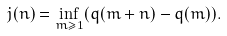Convert formula to latex. <formula><loc_0><loc_0><loc_500><loc_500>j ( n ) = \inf _ { m \geq 1 } ( q ( m + n ) - q ( m ) ) .</formula> 